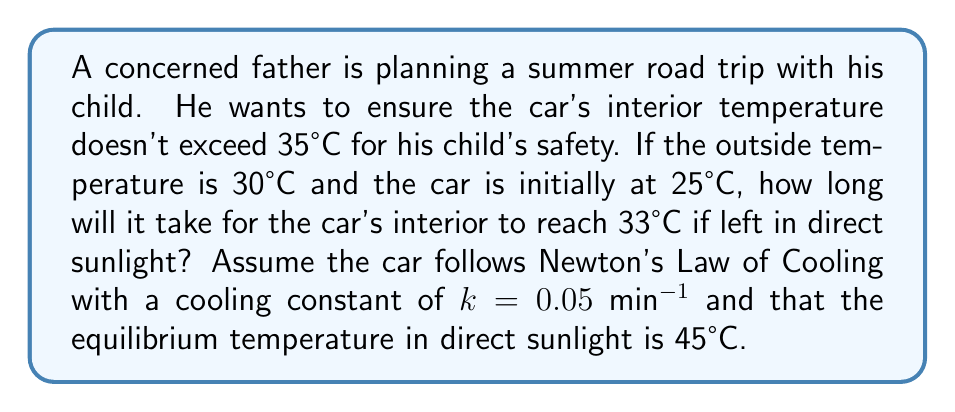Can you solve this math problem? Let's approach this step-by-step using Newton's Law of Cooling:

1) The general form of Newton's Law of Cooling is:

   $$\frac{dT}{dt} = k(T_e - T)$$

   Where:
   - $T$ is the temperature of the car at time $t$
   - $T_e$ is the equilibrium temperature (45°C in this case)
   - $k$ is the cooling constant (0.05 min^(-1))

2) The solution to this differential equation is:

   $$T(t) = T_e + (T_0 - T_e)e^{-kt}$$

   Where $T_0$ is the initial temperature (25°C)

3) We want to find $t$ when $T(t) = 33°C$. Let's substitute our values:

   $$33 = 45 + (25 - 45)e^{-0.05t}$$

4) Simplify:

   $$33 = 45 - 20e^{-0.05t}$$

5) Subtract 45 from both sides:

   $$-12 = -20e^{-0.05t}$$

6) Divide both sides by -20:

   $$0.6 = e^{-0.05t}$$

7) Take the natural logarithm of both sides:

   $$\ln(0.6) = -0.05t$$

8) Solve for $t$:

   $$t = \frac{-\ln(0.6)}{0.05} \approx 10.23 \text{ minutes}$$

Therefore, it will take approximately 10.23 minutes for the car's interior to reach 33°C.
Answer: 10.23 minutes 